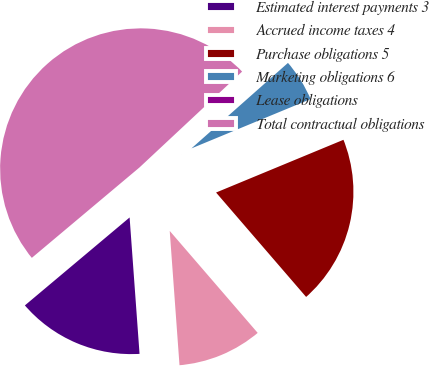Convert chart to OTSL. <chart><loc_0><loc_0><loc_500><loc_500><pie_chart><fcel>Estimated interest payments 3<fcel>Accrued income taxes 4<fcel>Purchase obligations 5<fcel>Marketing obligations 6<fcel>Lease obligations<fcel>Total contractual obligations<nl><fcel>15.04%<fcel>10.17%<fcel>19.92%<fcel>5.29%<fcel>0.42%<fcel>49.16%<nl></chart> 